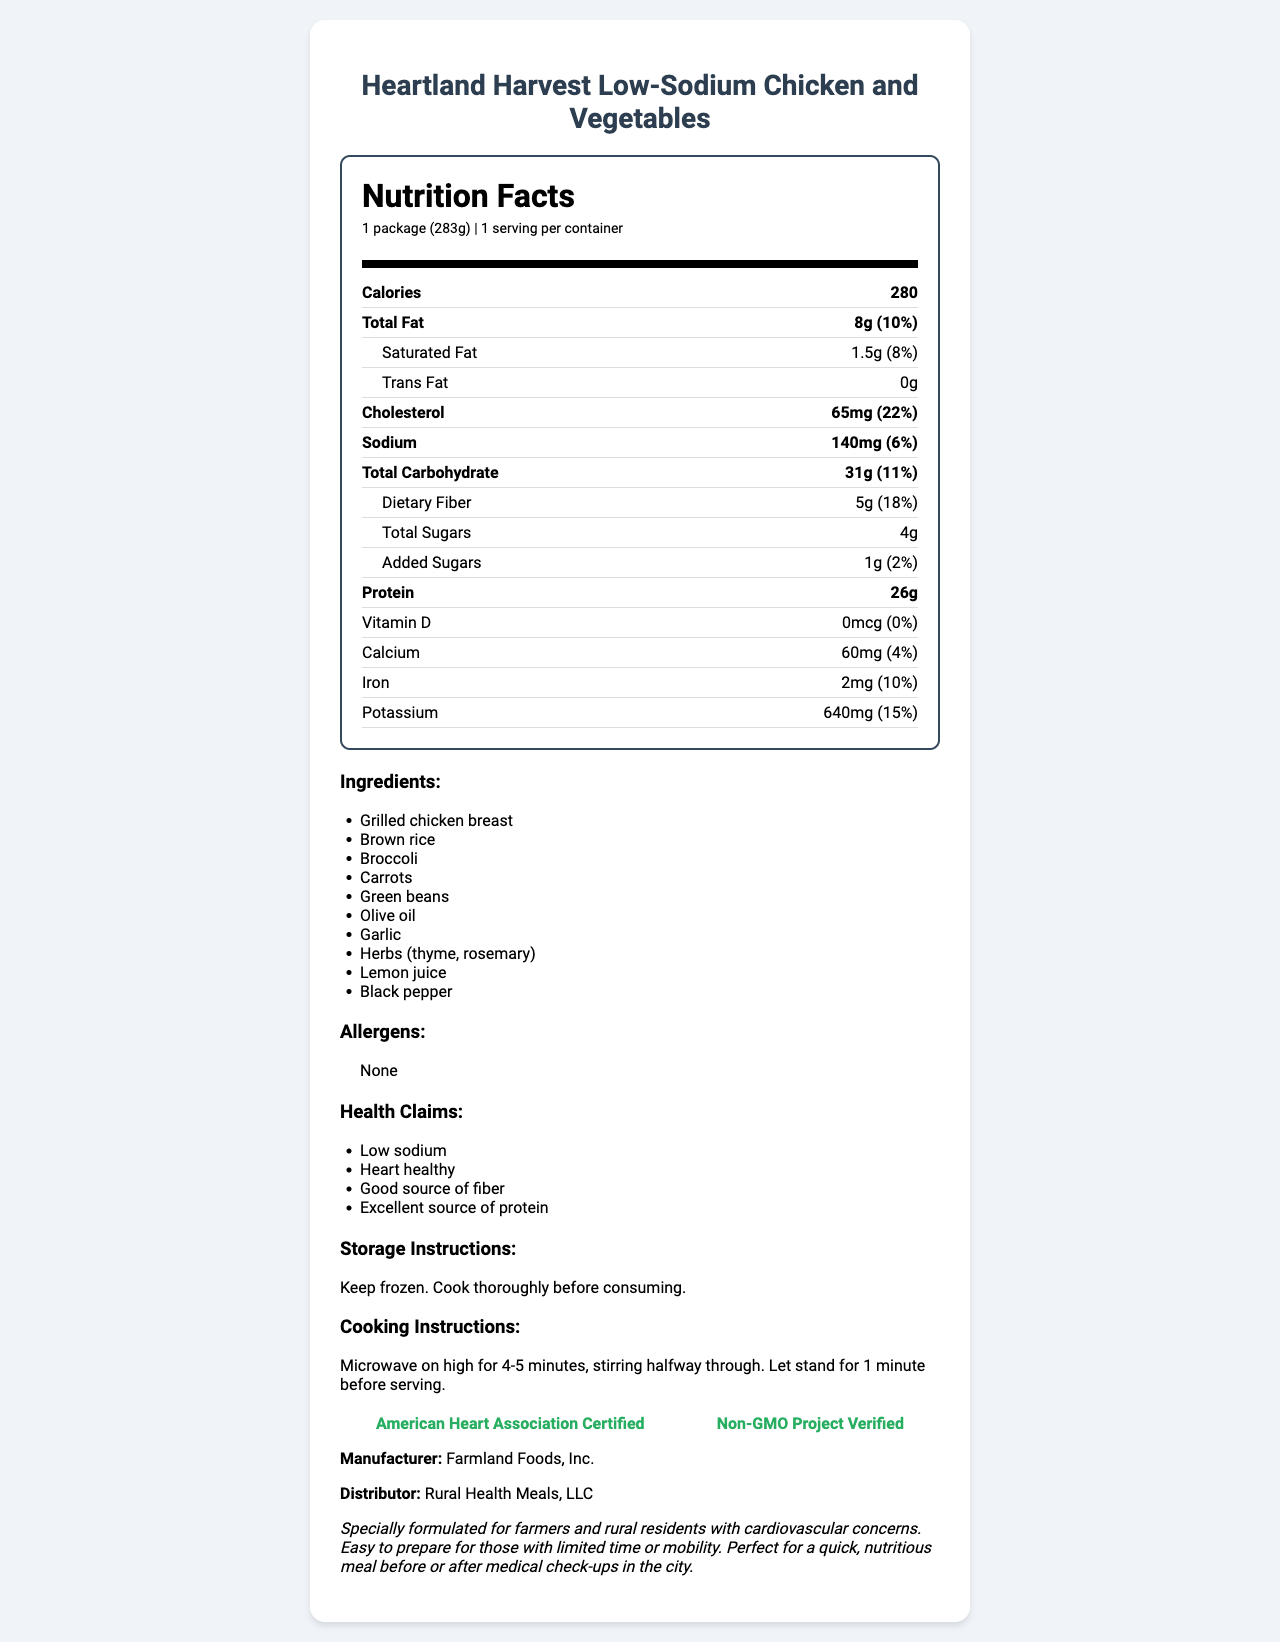what is the serving size for this product? The serving size is listed as "1 package (283g)" in the Nutrition Facts section.
Answer: 1 package (283g) how many calories are in one serving? The document shows that there are 280 calories in one serving of the product.
Answer: 280 what is the total fat content and its daily value percentage? The total fat content is 8g, which is 10% of the daily value as listed in the Nutrition Facts.
Answer: 8g, 10% what ingredients are included in this meal? The ingredients are listed under the "Ingredients" section of the document.
Answer: Grilled chicken breast, Brown rice, Broccoli, Carrots, Green beans, Olive oil, Garlic, Herbs (thyme, rosemary), Lemon juice, Black pepper what certifications does this product have? The certifications section mentions "American Heart Association Certified" and "Non-GMO Project Verified."
Answer: American Heart Association Certified, Non-GMO Project Verified what is the protein content per serving? The protein content is listed as 26g in the Nutrition Facts section.
Answer: 26g which claim is not correct for this product? A. Low sodium B. High in saturated fat C. Good source of fiber D. Excellent source of protein The document claims the product is low sodium, a good source of fiber, and an excellent source of protein. It does not claim to be high in saturated fat.
Answer: B what percentage of the daily value of iron does this product provide? The document lists that it provides 10% of the daily value for iron.
Answer: 10% is vitamin D present in this product? The document lists vitamin D as 0mcg, which is 0% of the daily value, meaning it is not present.
Answer: No who is the manufacturer of this product? The document specifies that the manufacturer is Farmland Foods, Inc.
Answer: Farmland Foods, Inc. summarize the key nutritional benefits of this product for someone with cardiovascular concerns. The document describes the product as heart-healthy and low in sodium, making it suitable for individuals with cardiovascular concerns. It also highlights high protein content and good source of fiber, which are beneficial for overall health.
Answer: The product, Heartland Harvest Low-Sodium Chicken and Vegetables, offers a low sodium meal option, contains high protein (26g), is a good source of fiber (5g), and has certifications from the American Heart Association and Non-GMO Project Verified. It is formulated for farmers and rural residents with cardiovascular concerns. how many steps are there in the cooking instructions? There are two steps in the cooking instructions: 1) Microwave on high for 4-5 minutes, stirring halfway through. 2) Let stand for 1 minute before serving.
Answer: 2 how much cholesterol is in one serving and what is its daily value percentage? The document lists the cholesterol content as 65mg, which is 22% of the daily value.
Answer: 65mg, 22% what is the storage instruction for this product? A. Refrigerate B. Keep frozen C. Store in a cool, dry place D. Do not store The storage instructions state "Keep frozen."
Answer: B how long does it take to cook this meal in a microwave? The cooking instructions indicate microwaving on high for 4-5 minutes.
Answer: 4-5 minutes can this product be suitable for someone tracking their potassium intake? The document shows that the product contains 640mg of potassium, which is 15% of the daily value, and this information is likely useful for someone tracking their potassium intake.
Answer: Yes what allergens are present in this product? The document lists that there are no allergens present in this product.
Answer: None what company distributes this product? The distributor of the product is listed as Rural Health Meals, LLC.
Answer: Rural Health Meals, LLC what is the total carbohydrate content and its daily value percentage? The total carbohydrate content is 31g, which is 11% of the daily value.
Answer: 31g, 11% is this product high in added sugars? The product contains only 1g of added sugars, which is 2% of the daily value, indicating it is not high in added sugars.
Answer: No who is the target audience for this product? The additional information specifies that the product is specially formulated for farmers and rural residents with cardiovascular concerns.
Answer: Farmers and rural residents with cardiovascular concerns what is the fat content split between saturated and trans fats? The document lists 1.5g of saturated fat and 0g of trans fat.
Answer: 1.5g of saturated fat, 0g of trans fat 